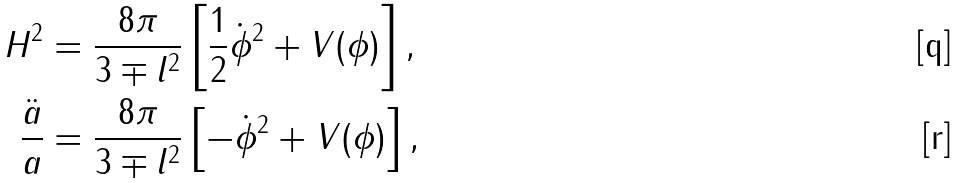<formula> <loc_0><loc_0><loc_500><loc_500>H ^ { 2 } & = \frac { 8 \pi } { 3 \mp l ^ { 2 } } \left [ \frac { 1 } { 2 } \dot { \phi } ^ { 2 } + V ( \phi ) \right ] , \\ \frac { \ddot { a } } { a } & = \frac { 8 \pi } { 3 \mp l ^ { 2 } } \left [ - \dot { \phi } ^ { 2 } + V ( \phi ) \right ] ,</formula> 